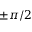<formula> <loc_0><loc_0><loc_500><loc_500>\pm \pi / 2</formula> 